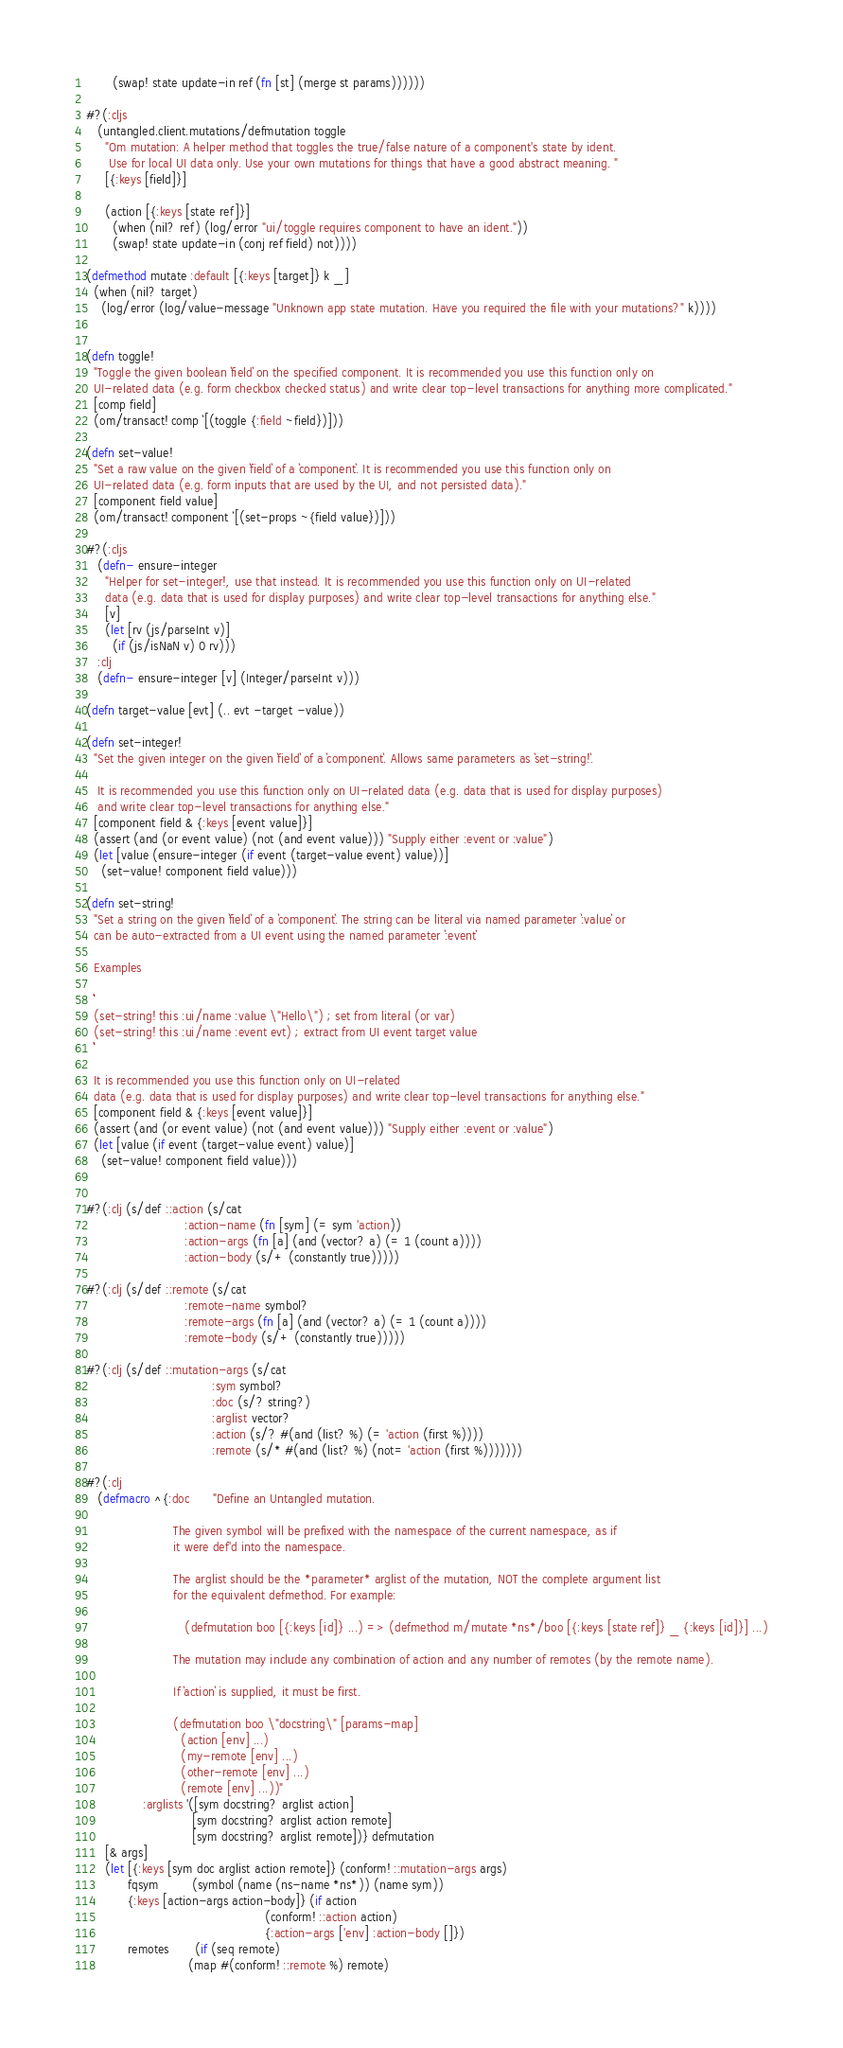Convert code to text. <code><loc_0><loc_0><loc_500><loc_500><_Clojure_>       (swap! state update-in ref (fn [st] (merge st params))))))

#?(:cljs
   (untangled.client.mutations/defmutation toggle
     "Om mutation: A helper method that toggles the true/false nature of a component's state by ident.
      Use for local UI data only. Use your own mutations for things that have a good abstract meaning. "
     [{:keys [field]}]

     (action [{:keys [state ref]}]
       (when (nil? ref) (log/error "ui/toggle requires component to have an ident."))
       (swap! state update-in (conj ref field) not))))

(defmethod mutate :default [{:keys [target]} k _]
  (when (nil? target)
    (log/error (log/value-message "Unknown app state mutation. Have you required the file with your mutations?" k))))


(defn toggle!
  "Toggle the given boolean `field` on the specified component. It is recommended you use this function only on
  UI-related data (e.g. form checkbox checked status) and write clear top-level transactions for anything more complicated."
  [comp field]
  (om/transact! comp `[(toggle {:field ~field})]))

(defn set-value!
  "Set a raw value on the given `field` of a `component`. It is recommended you use this function only on
  UI-related data (e.g. form inputs that are used by the UI, and not persisted data)."
  [component field value]
  (om/transact! component `[(set-props ~{field value})]))

#?(:cljs
   (defn- ensure-integer
     "Helper for set-integer!, use that instead. It is recommended you use this function only on UI-related
     data (e.g. data that is used for display purposes) and write clear top-level transactions for anything else."
     [v]
     (let [rv (js/parseInt v)]
       (if (js/isNaN v) 0 rv)))
   :clj
   (defn- ensure-integer [v] (Integer/parseInt v)))

(defn target-value [evt] (.. evt -target -value))

(defn set-integer!
  "Set the given integer on the given `field` of a `component`. Allows same parameters as `set-string!`.

   It is recommended you use this function only on UI-related data (e.g. data that is used for display purposes)
   and write clear top-level transactions for anything else."
  [component field & {:keys [event value]}]
  (assert (and (or event value) (not (and event value))) "Supply either :event or :value")
  (let [value (ensure-integer (if event (target-value event) value))]
    (set-value! component field value)))

(defn set-string!
  "Set a string on the given `field` of a `component`. The string can be literal via named parameter `:value` or
  can be auto-extracted from a UI event using the named parameter `:event`

  Examples

  ```
  (set-string! this :ui/name :value \"Hello\") ; set from literal (or var)
  (set-string! this :ui/name :event evt) ; extract from UI event target value
  ```

  It is recommended you use this function only on UI-related
  data (e.g. data that is used for display purposes) and write clear top-level transactions for anything else."
  [component field & {:keys [event value]}]
  (assert (and (or event value) (not (and event value))) "Supply either :event or :value")
  (let [value (if event (target-value event) value)]
    (set-value! component field value)))


#?(:clj (s/def ::action (s/cat
                          :action-name (fn [sym] (= sym 'action))
                          :action-args (fn [a] (and (vector? a) (= 1 (count a))))
                          :action-body (s/+ (constantly true)))))

#?(:clj (s/def ::remote (s/cat
                          :remote-name symbol?
                          :remote-args (fn [a] (and (vector? a) (= 1 (count a))))
                          :remote-body (s/+ (constantly true)))))

#?(:clj (s/def ::mutation-args (s/cat
                                 :sym symbol?
                                 :doc (s/? string?)
                                 :arglist vector?
                                 :action (s/? #(and (list? %) (= 'action (first %))))
                                 :remote (s/* #(and (list? %) (not= 'action (first %)))))))

#?(:clj
   (defmacro ^{:doc      "Define an Untangled mutation.

                       The given symbol will be prefixed with the namespace of the current namespace, as if
                       it were def'd into the namespace.

                       The arglist should be the *parameter* arglist of the mutation, NOT the complete argument list
                       for the equivalent defmethod. For example:

                          (defmutation boo [{:keys [id]} ...) => (defmethod m/mutate *ns*/boo [{:keys [state ref]} _ {:keys [id]}] ...)

                       The mutation may include any combination of action and any number of remotes (by the remote name).

                       If `action` is supplied, it must be first.

                       (defmutation boo \"docstring\" [params-map]
                         (action [env] ...)
                         (my-remote [env] ...)
                         (other-remote [env] ...)
                         (remote [env] ...))"
               :arglists '([sym docstring? arglist action]
                            [sym docstring? arglist action remote]
                            [sym docstring? arglist remote])} defmutation
     [& args]
     (let [{:keys [sym doc arglist action remote]} (conform! ::mutation-args args)
           fqsym         (symbol (name (ns-name *ns*)) (name sym))
           {:keys [action-args action-body]} (if action
                                               (conform! ::action action)
                                               {:action-args ['env] :action-body []})
           remotes       (if (seq remote)
                           (map #(conform! ::remote %) remote)</code> 